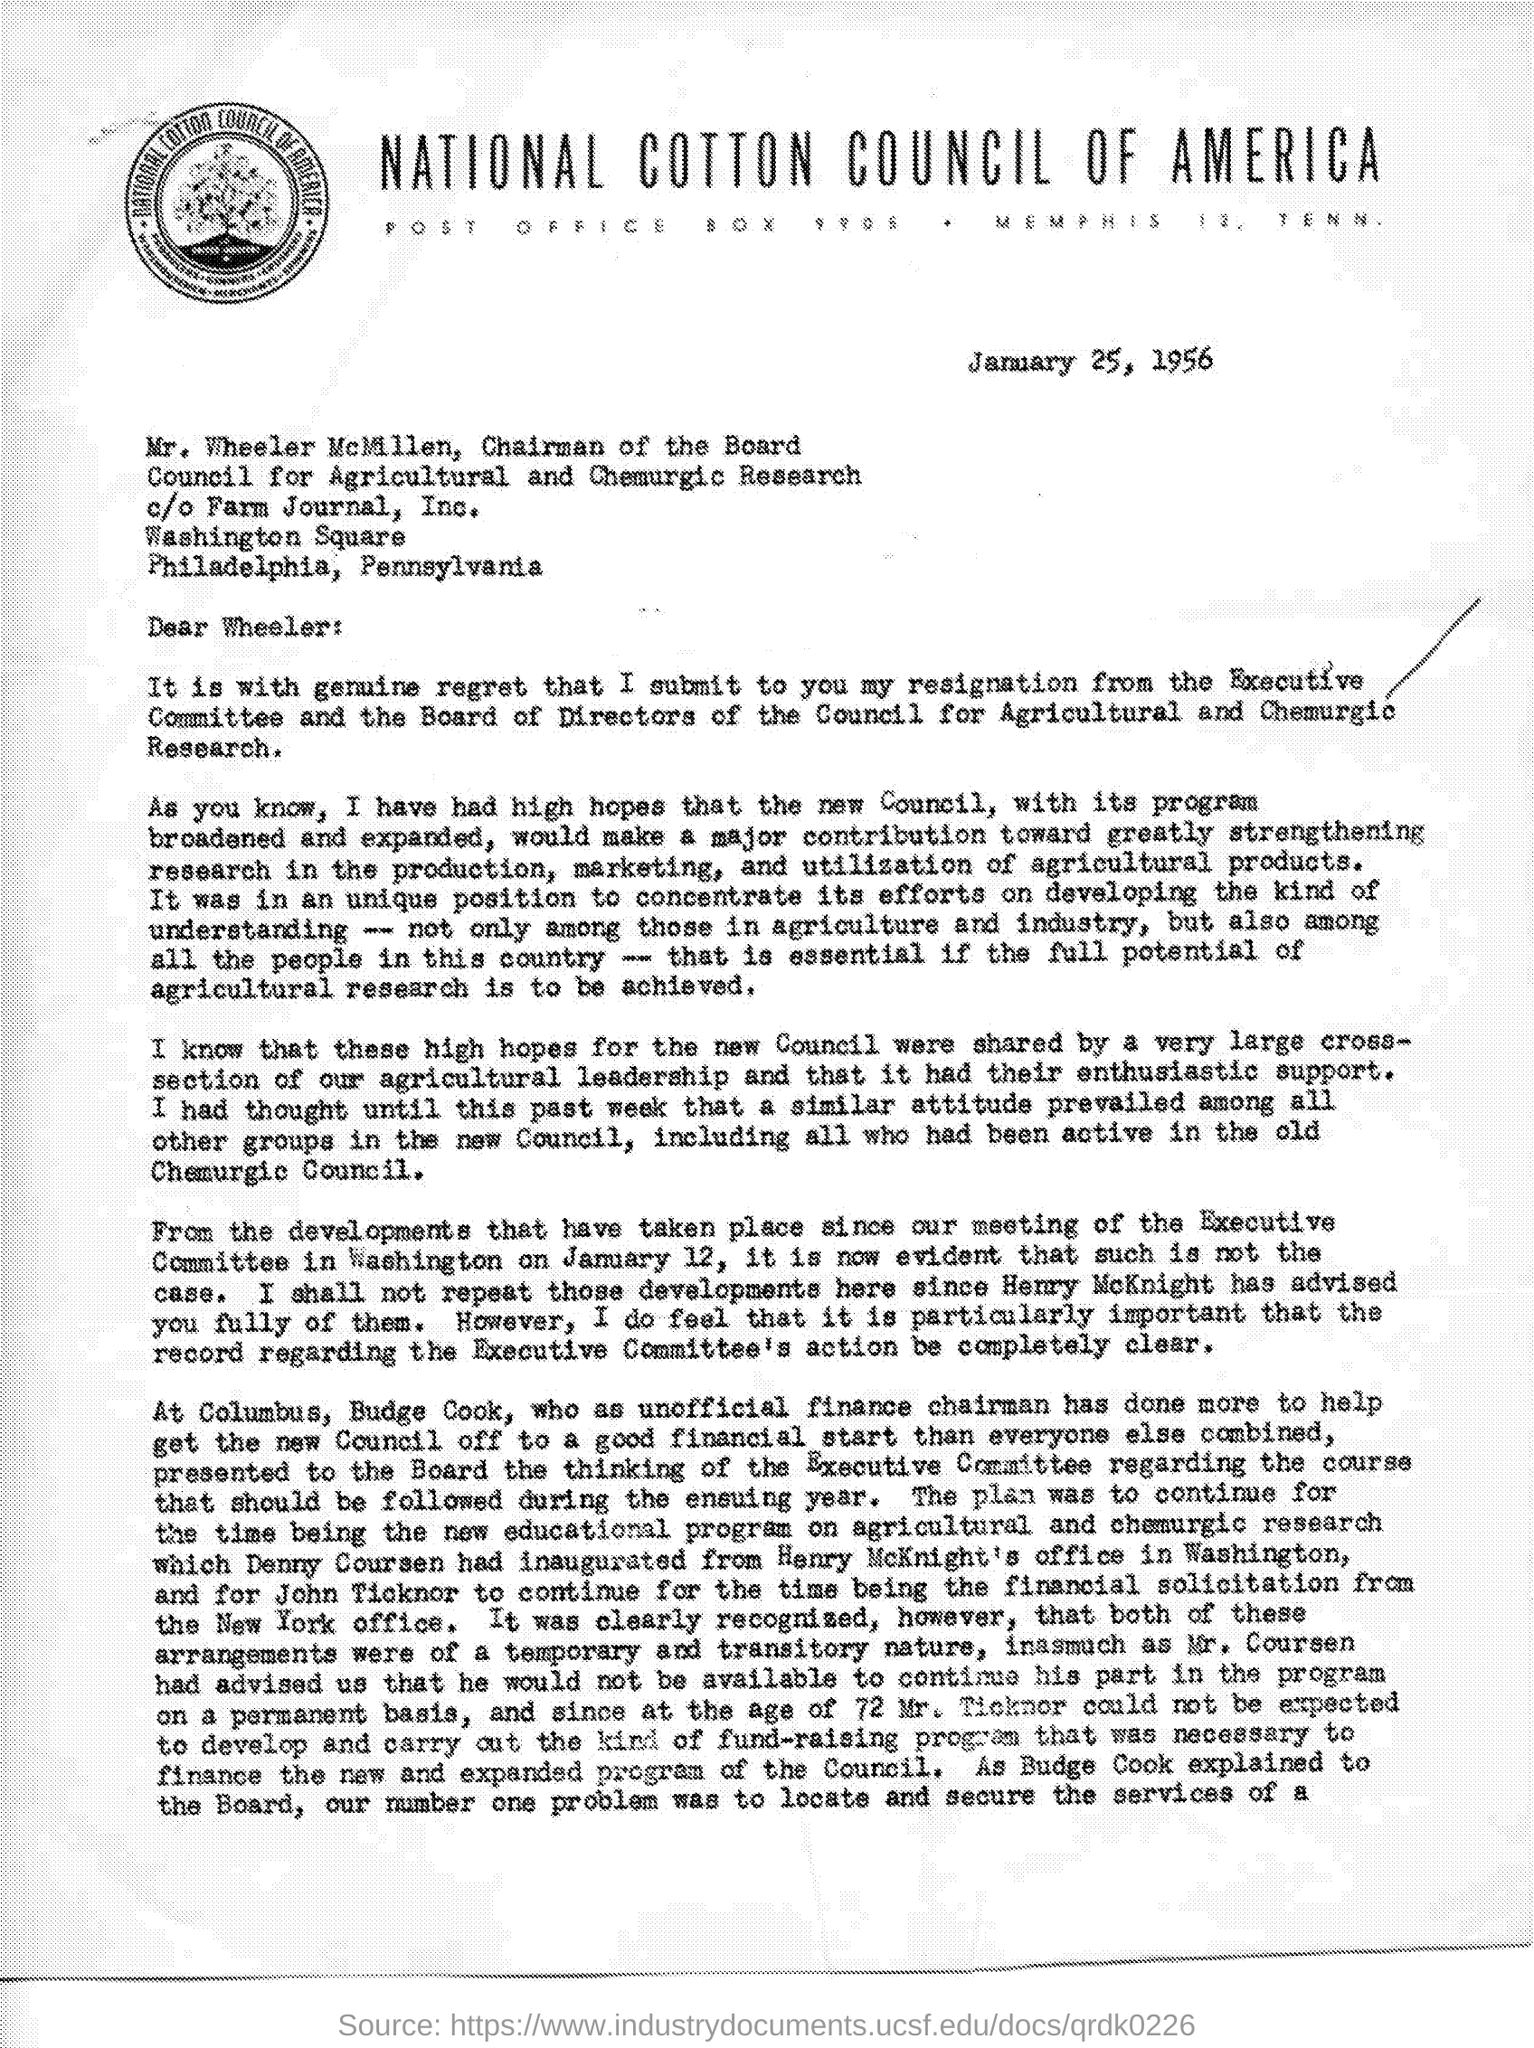Which institution is mentioned at the top of the page?
Your answer should be very brief. NATIONAL COTTON COUNCIL OF AMERICA. To whom is the letter addressed?
Provide a short and direct response. Wheeler. When is the letter dated?
Provide a short and direct response. January 25, 1956. 